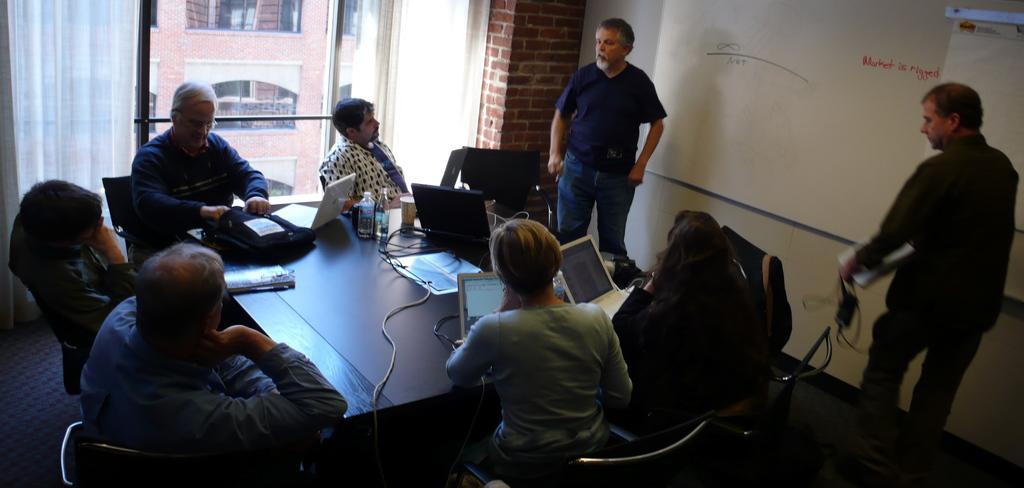Can you describe this image briefly? In this image we can see two persons are standing, in front there is a white board, here are group of people sitting on the chairs, in front here is the table, and laptop on it, here are the wires, here are the bottles, and some objects on it, there is the window glass, there is the curtain, there is a building. 